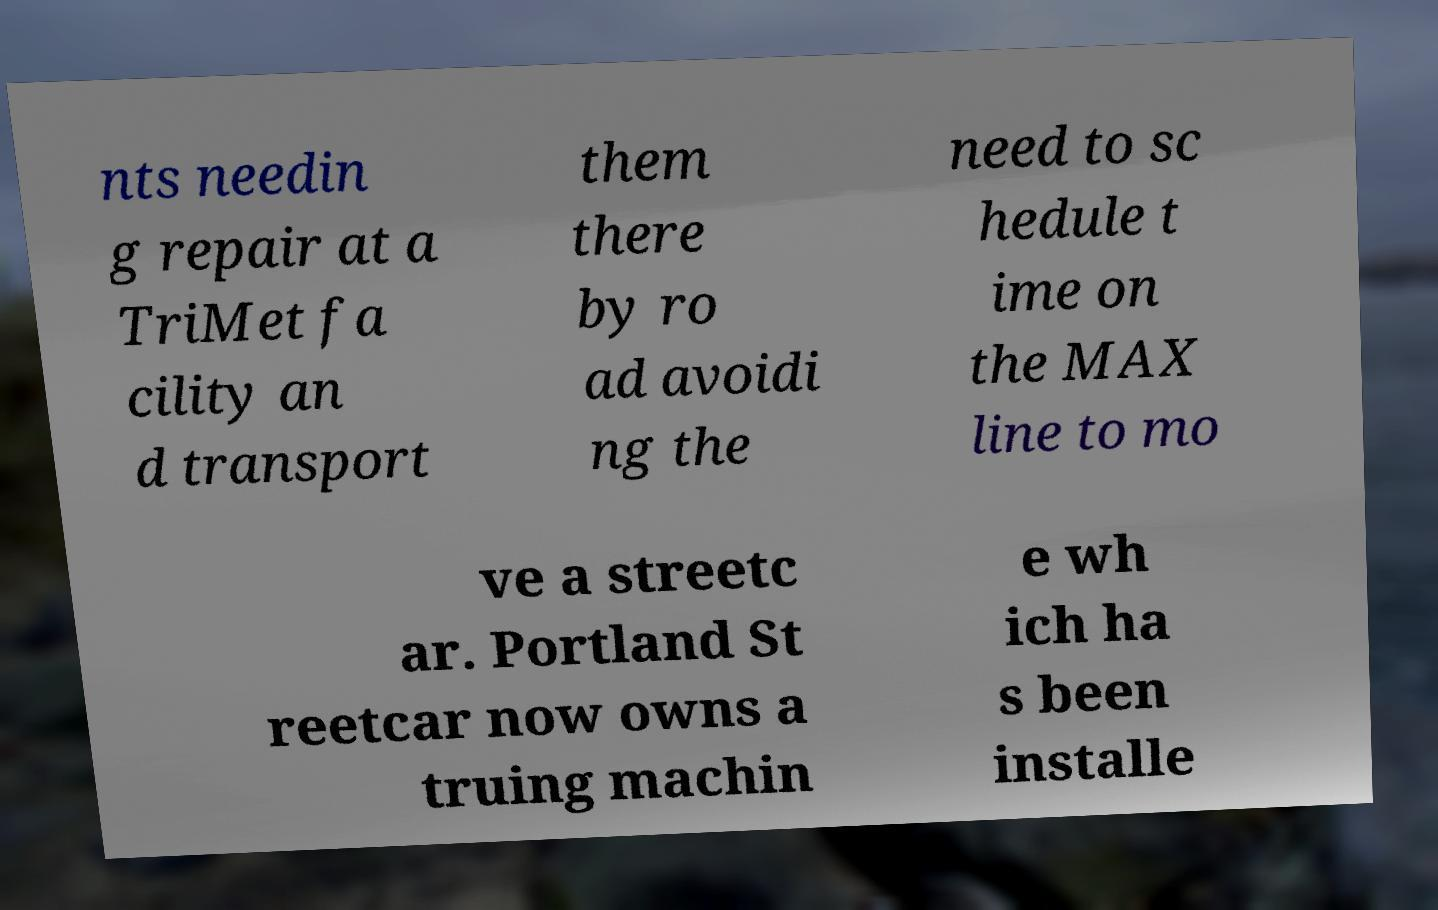There's text embedded in this image that I need extracted. Can you transcribe it verbatim? nts needin g repair at a TriMet fa cility an d transport them there by ro ad avoidi ng the need to sc hedule t ime on the MAX line to mo ve a streetc ar. Portland St reetcar now owns a truing machin e wh ich ha s been installe 